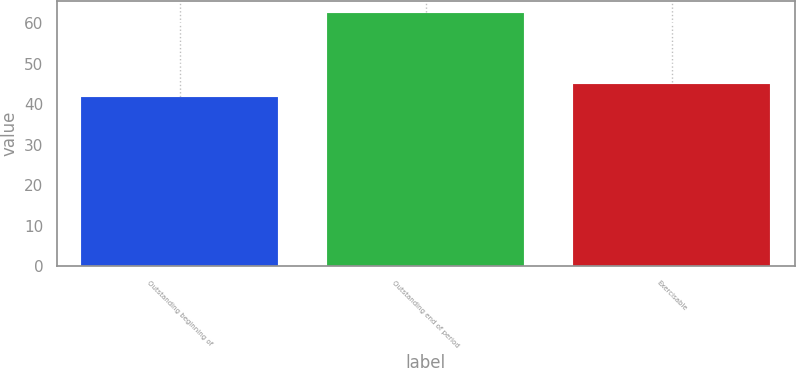Convert chart to OTSL. <chart><loc_0><loc_0><loc_500><loc_500><bar_chart><fcel>Outstanding beginning of<fcel>Outstanding end of period<fcel>Exercisable<nl><fcel>41.87<fcel>62.5<fcel>45.12<nl></chart> 